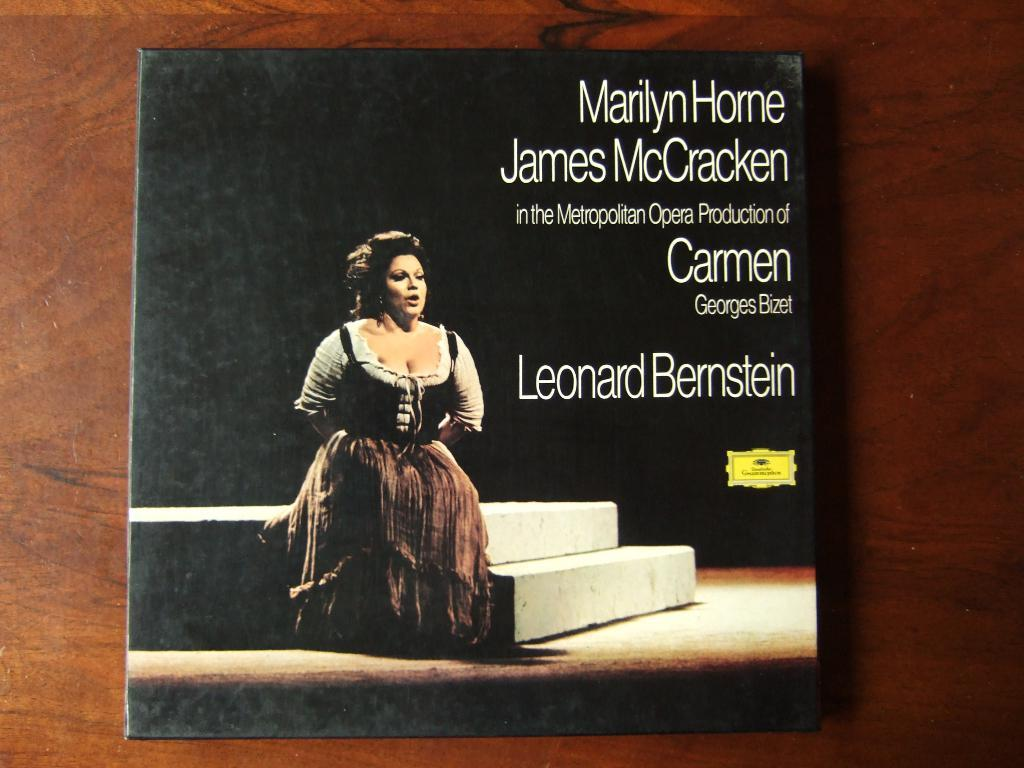<image>
Write a terse but informative summary of the picture. A woman singing opera is on the cover of an advertisement for the Metropolitan Opera Production of Carmen. 